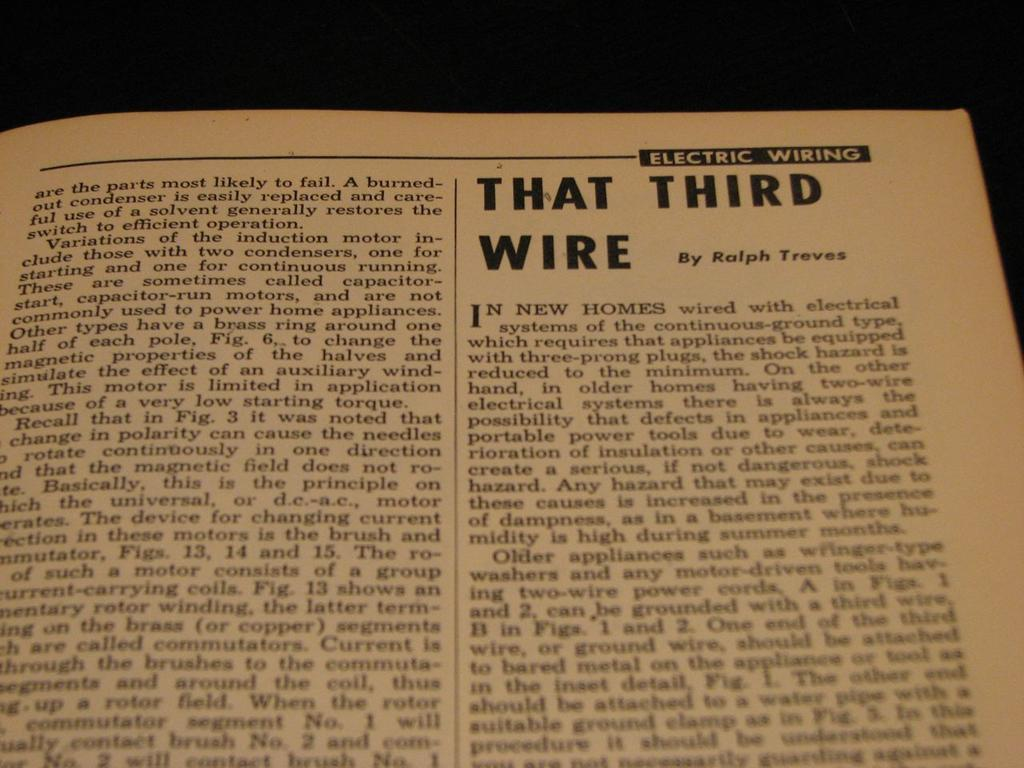<image>
Describe the image concisely. In the electric wiring manual, it talks about that third wire. 